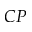Convert formula to latex. <formula><loc_0><loc_0><loc_500><loc_500>C P</formula> 